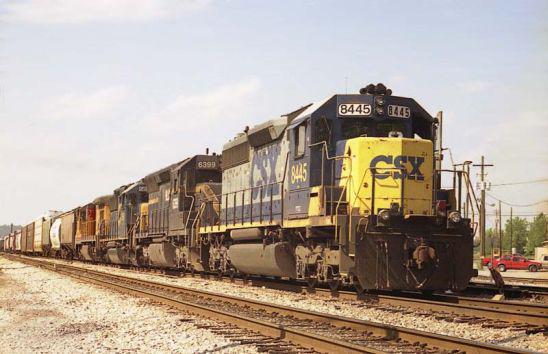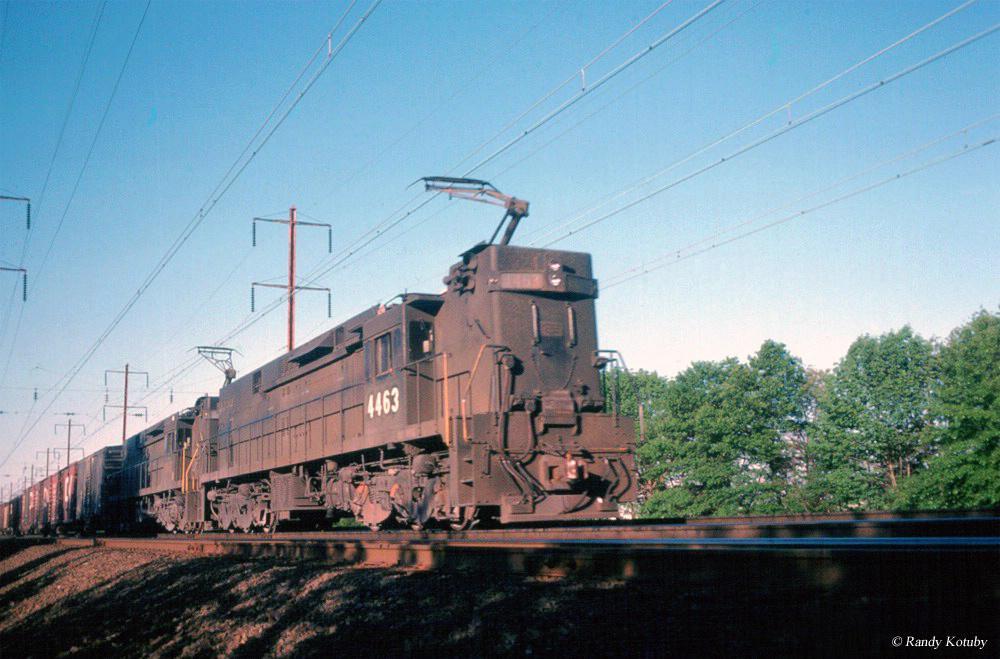The first image is the image on the left, the second image is the image on the right. Considering the images on both sides, is "Multiple tracks are visible in the left image." valid? Answer yes or no. Yes. The first image is the image on the left, the second image is the image on the right. Evaluate the accuracy of this statement regarding the images: "in at least one image a train has headlights on". Is it true? Answer yes or no. No. 